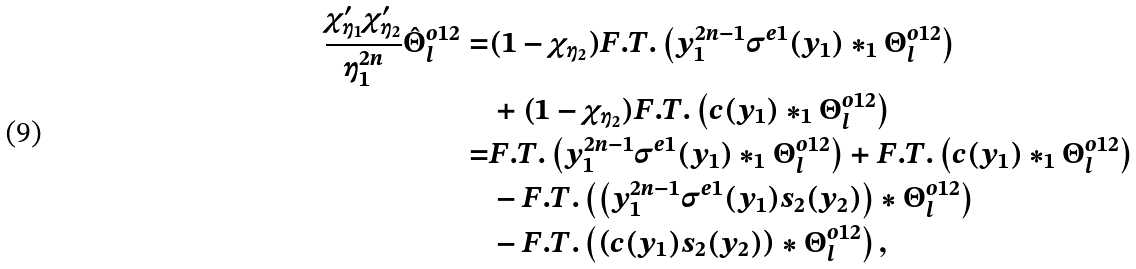Convert formula to latex. <formula><loc_0><loc_0><loc_500><loc_500>\frac { \chi _ { \eta _ { 1 } } ^ { \prime } \chi _ { \eta _ { 2 } } ^ { \prime } } { \eta _ { 1 } ^ { 2 n } } \hat { \Theta } _ { l } ^ { o 1 2 } = & ( 1 - \chi _ { \eta _ { 2 } } ) F . T . \left ( y _ { 1 } ^ { 2 n - 1 } \sigma ^ { e 1 } ( y _ { 1 } ) \ast _ { 1 } \Theta _ { l } ^ { o 1 2 } \right ) \\ & + ( 1 - \chi _ { \eta _ { 2 } } ) F . T . \left ( c ( y _ { 1 } ) \ast _ { 1 } \Theta _ { l } ^ { o 1 2 } \right ) \\ = & F . T . \left ( y _ { 1 } ^ { 2 n - 1 } \sigma ^ { e 1 } ( y _ { 1 } ) \ast _ { 1 } \Theta _ { l } ^ { o 1 2 } \right ) + F . T . \left ( c ( y _ { 1 } ) \ast _ { 1 } \Theta _ { l } ^ { o 1 2 } \right ) \\ & - F . T . \left ( \left ( y _ { 1 } ^ { 2 n - 1 } \sigma ^ { e 1 } ( y _ { 1 } ) s _ { 2 } ( y _ { 2 } ) \right ) \ast \Theta _ { l } ^ { o 1 2 } \right ) \\ & - F . T . \left ( \left ( c ( y _ { 1 } ) s _ { 2 } ( y _ { 2 } ) \right ) \ast \Theta _ { l } ^ { o 1 2 } \right ) ,</formula> 